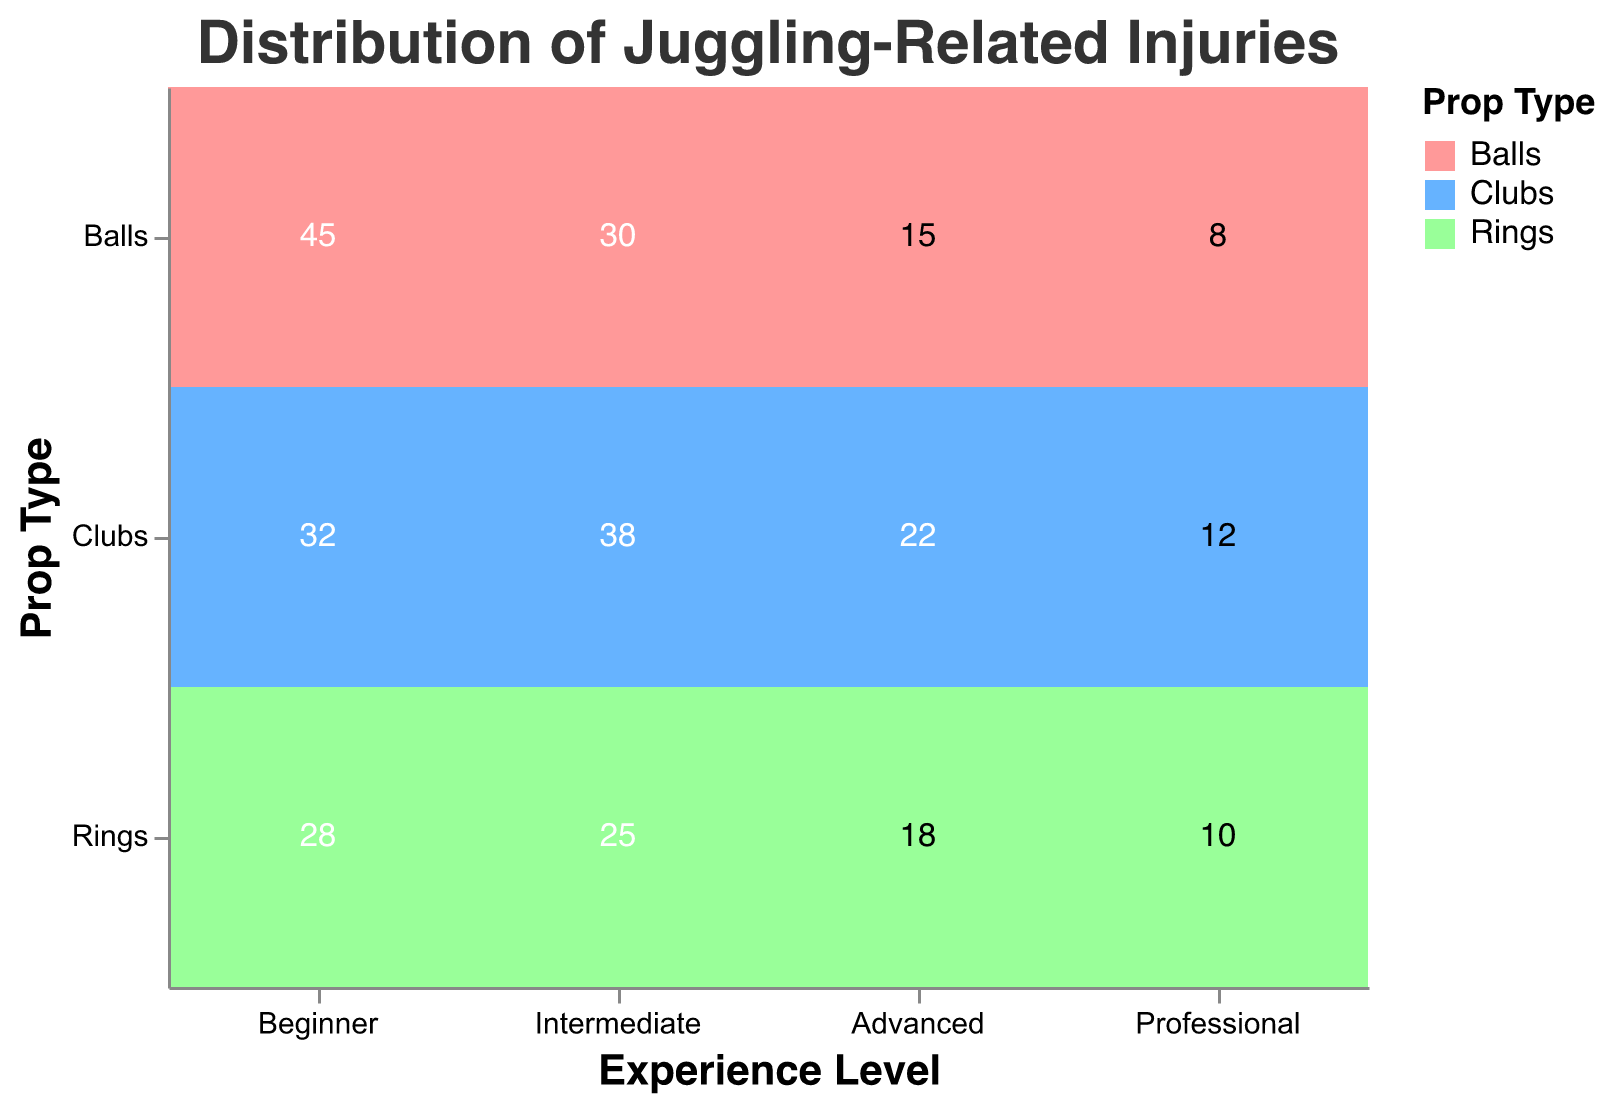What is the total number of injuries for beginners? To find the total number of injuries for beginners, we need to sum the injury counts for all prop types within the beginner experience level. The values are 45 for balls, 32 for clubs, and 28 for rings. Summing these gives 45 + 32 + 28 = 105.
Answer: 105 Which experience level has the least number of injuries with rings? To determine this, we compare the injury counts for rings across all experience levels: Beginner (28), Intermediate (25), Advanced (18), and Professional (10). The lowest value is 10, which corresponds to the Professional experience level.
Answer: Professional How many more injuries do intermediate jugglers have with clubs compared to advanced jugglers with clubs? We compare the injury counts for intermediate and advanced jugglers using clubs. Intermediate jugglers have 38 injuries, while advanced jugglers have 22 injuries. The difference is 38 - 22 = 16.
Answer: 16 What proportion of the total injuries in advanced level are caused by balls? First, we find the total number of injuries for advanced level jugglers: Balls (15), Clubs (22), Rings (18). Summing these gives 15 + 22 + 18 = 55. The injury count for balls is 15. The proportion is calculated as 15 / 55.
Answer: 15/55 (approximately 0.273) Which prop type has the highest number of injuries among all professionals? To find this, we compare the injury counts for all prop types within the professional experience level: Balls (8), Clubs (12), Rings (10). The highest injury count is 12, which corresponds to clubs.
Answer: Clubs 